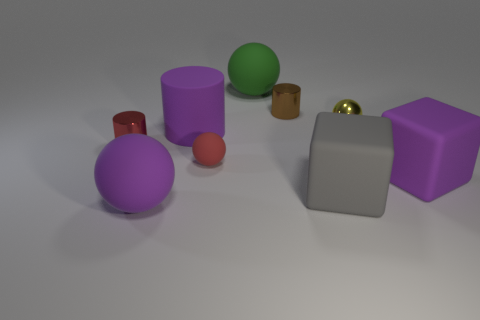What is the material of the big ball that is behind the big purple rubber object right of the tiny brown object?
Provide a short and direct response. Rubber. What number of matte cubes have the same color as the large matte cylinder?
Give a very brief answer. 1. The red ball that is made of the same material as the green sphere is what size?
Make the answer very short. Small. There is a purple thing that is on the right side of the shiny sphere; what is its shape?
Give a very brief answer. Cube. The other shiny object that is the same shape as the tiny brown thing is what size?
Provide a succinct answer. Small. There is a thing right of the small thing to the right of the tiny brown shiny object; how many small red things are behind it?
Offer a very short reply. 2. Are there an equal number of shiny balls in front of the red rubber thing and purple balls?
Your answer should be very brief. No. How many balls are tiny red rubber objects or small yellow things?
Your answer should be very brief. 2. Is the small matte ball the same color as the shiny ball?
Give a very brief answer. No. Are there an equal number of small red things that are in front of the small red cylinder and tiny yellow shiny balls in front of the small rubber ball?
Make the answer very short. No. 